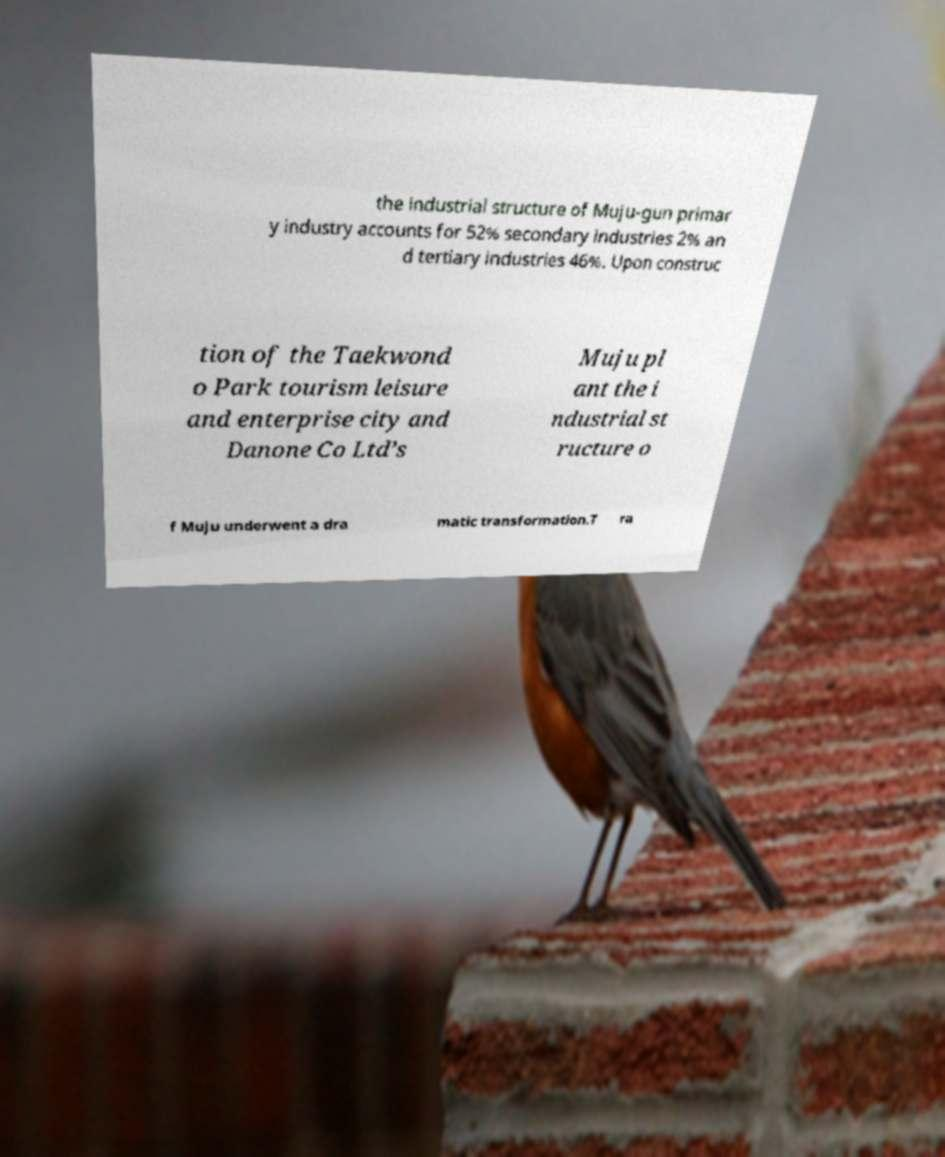There's text embedded in this image that I need extracted. Can you transcribe it verbatim? the industrial structure of Muju-gun primar y industry accounts for 52% secondary industries 2% an d tertiary industries 46%. Upon construc tion of the Taekwond o Park tourism leisure and enterprise city and Danone Co Ltd’s Muju pl ant the i ndustrial st ructure o f Muju underwent a dra matic transformation.T ra 